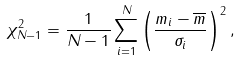Convert formula to latex. <formula><loc_0><loc_0><loc_500><loc_500>\chi ^ { 2 } _ { N - 1 } = \frac { 1 } { N - 1 } \sum _ { i = 1 } ^ { N } \left ( \frac { m _ { i } - \overline { m } } { \sigma _ { i } } \right ) ^ { 2 } ,</formula> 